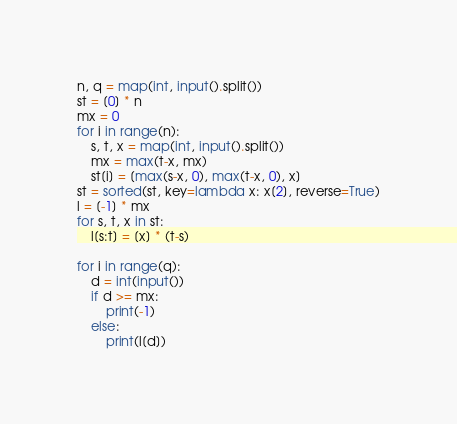<code> <loc_0><loc_0><loc_500><loc_500><_Python_>n, q = map(int, input().split())
st = [0] * n
mx = 0
for i in range(n):
    s, t, x = map(int, input().split())
    mx = max(t-x, mx)
    st[i] = [max(s-x, 0), max(t-x, 0), x]
st = sorted(st, key=lambda x: x[2], reverse=True)
l = [-1] * mx
for s, t, x in st:
    l[s:t] = [x] * (t-s)

for i in range(q):
    d = int(input())
    if d >= mx:
        print(-1)
    else:
        print(l[d])
</code> 